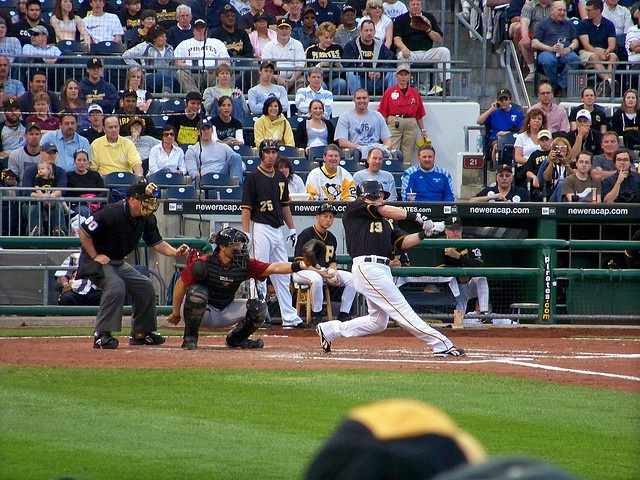Describe the objects in this image and their specific colors. I can see people in darkblue, black, gray, and lightgray tones, people in darkblue, black, lavender, darkgray, and gray tones, people in darkblue, black, gray, and brown tones, people in darkblue, black, gray, maroon, and darkgray tones, and people in darkblue, black, lavender, and darkgray tones in this image. 